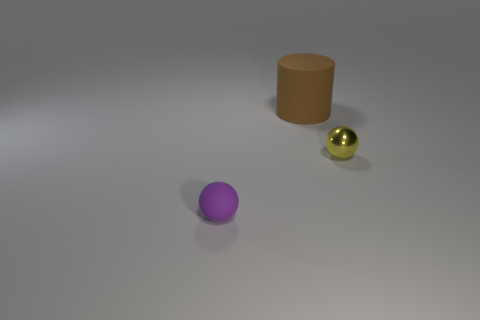Add 3 small cyan cylinders. How many objects exist? 6 Subtract all cylinders. How many objects are left? 2 Subtract all tiny spheres. Subtract all rubber cylinders. How many objects are left? 0 Add 2 tiny purple things. How many tiny purple things are left? 3 Add 2 rubber cylinders. How many rubber cylinders exist? 3 Subtract 0 green spheres. How many objects are left? 3 